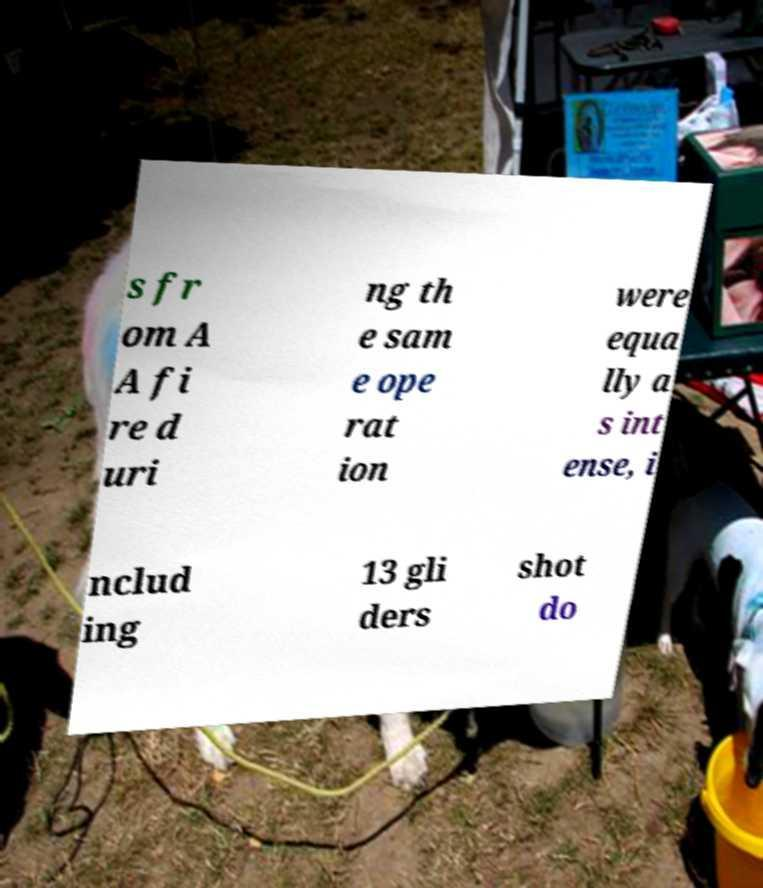Can you accurately transcribe the text from the provided image for me? s fr om A A fi re d uri ng th e sam e ope rat ion were equa lly a s int ense, i nclud ing 13 gli ders shot do 